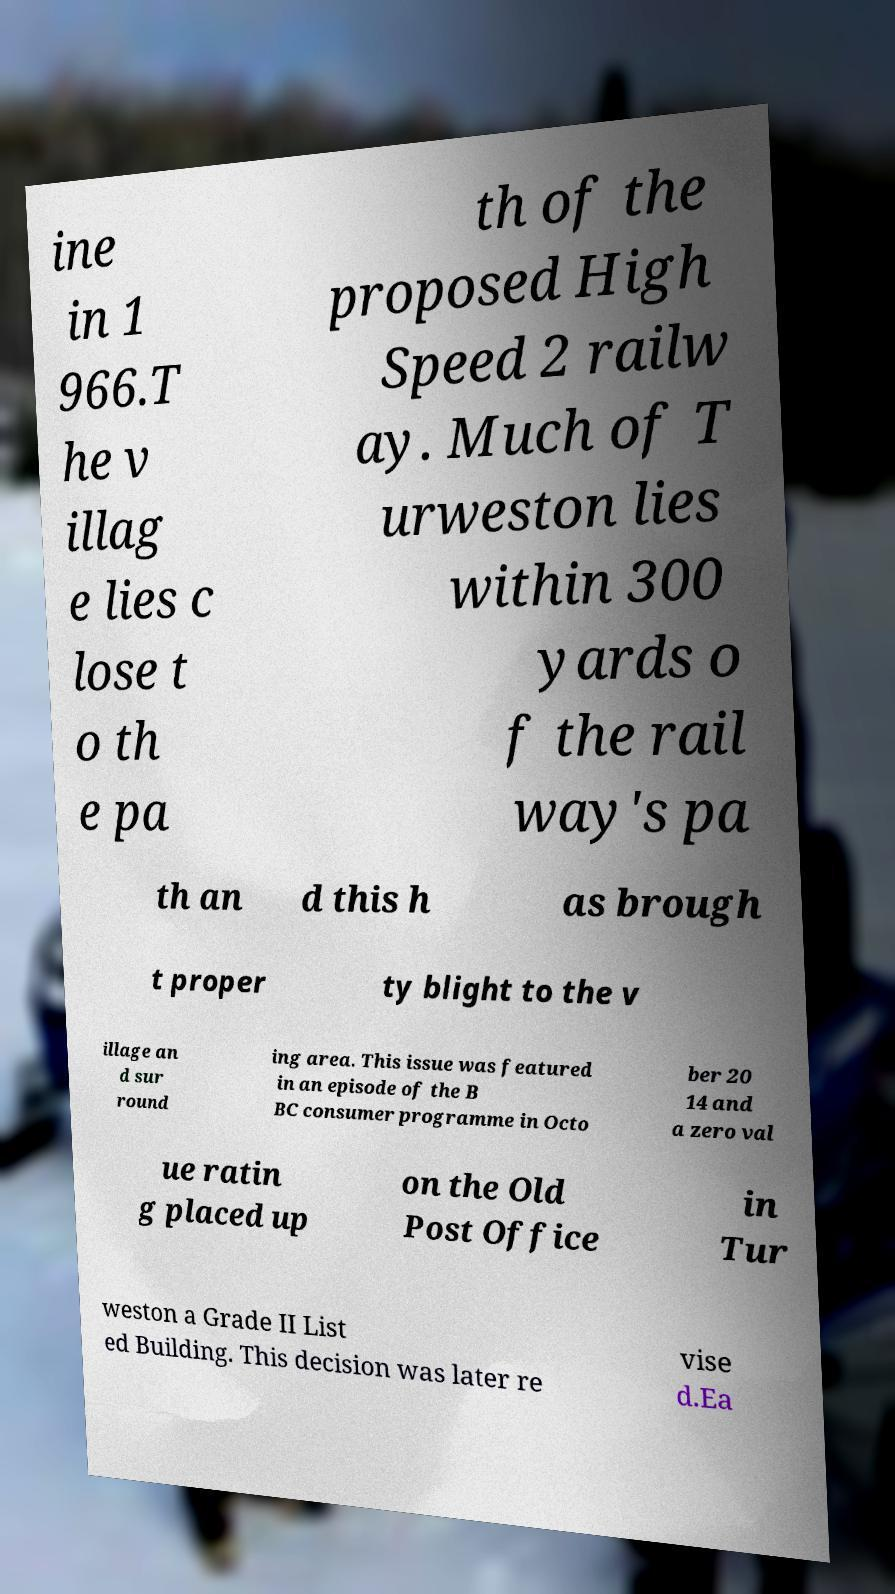Could you extract and type out the text from this image? ine in 1 966.T he v illag e lies c lose t o th e pa th of the proposed High Speed 2 railw ay. Much of T urweston lies within 300 yards o f the rail way's pa th an d this h as brough t proper ty blight to the v illage an d sur round ing area. This issue was featured in an episode of the B BC consumer programme in Octo ber 20 14 and a zero val ue ratin g placed up on the Old Post Office in Tur weston a Grade II List ed Building. This decision was later re vise d.Ea 